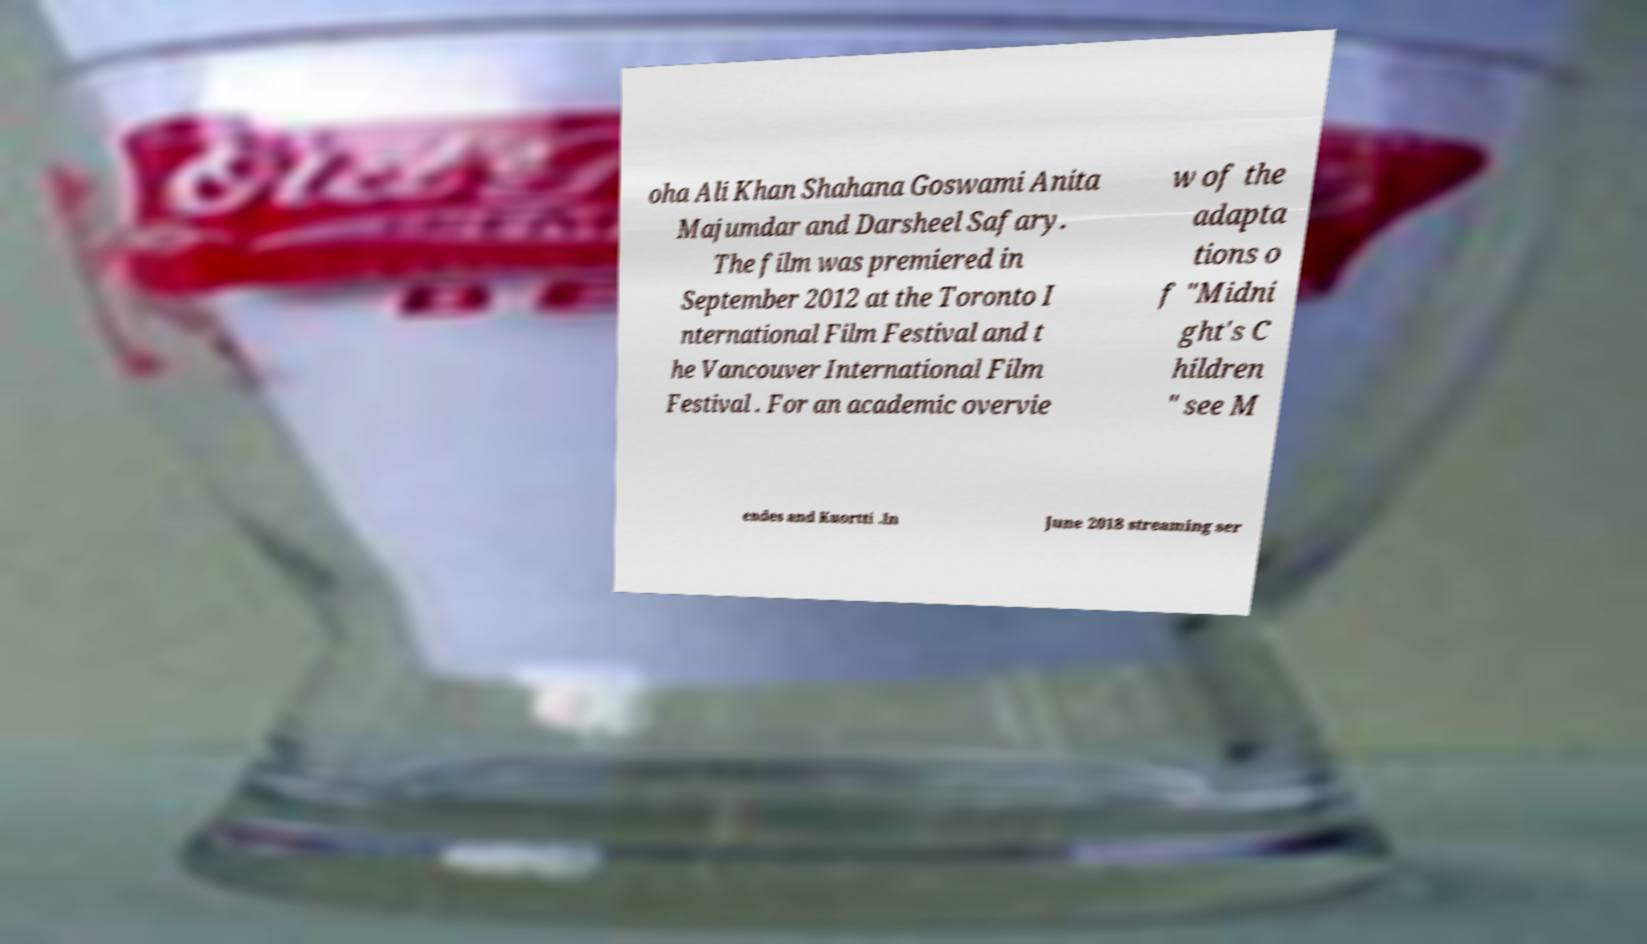There's text embedded in this image that I need extracted. Can you transcribe it verbatim? oha Ali Khan Shahana Goswami Anita Majumdar and Darsheel Safary. The film was premiered in September 2012 at the Toronto I nternational Film Festival and t he Vancouver International Film Festival . For an academic overvie w of the adapta tions o f "Midni ght's C hildren " see M endes and Kuortti .In June 2018 streaming ser 